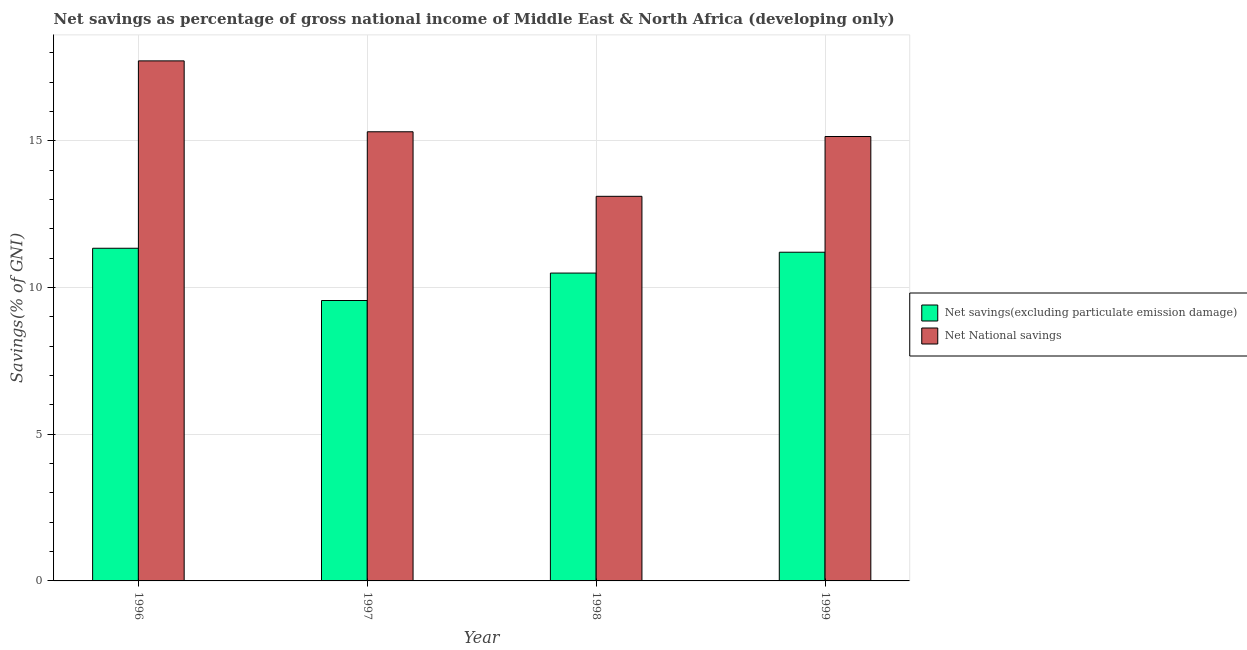How many groups of bars are there?
Offer a terse response. 4. How many bars are there on the 1st tick from the right?
Make the answer very short. 2. What is the label of the 1st group of bars from the left?
Your answer should be very brief. 1996. In how many cases, is the number of bars for a given year not equal to the number of legend labels?
Make the answer very short. 0. What is the net savings(excluding particulate emission damage) in 1996?
Your response must be concise. 11.34. Across all years, what is the maximum net national savings?
Your response must be concise. 17.72. Across all years, what is the minimum net savings(excluding particulate emission damage)?
Make the answer very short. 9.56. What is the total net national savings in the graph?
Your answer should be very brief. 61.28. What is the difference between the net savings(excluding particulate emission damage) in 1996 and that in 1998?
Your answer should be compact. 0.85. What is the difference between the net national savings in 1997 and the net savings(excluding particulate emission damage) in 1996?
Provide a short and direct response. -2.42. What is the average net national savings per year?
Offer a very short reply. 15.32. What is the ratio of the net savings(excluding particulate emission damage) in 1996 to that in 1997?
Make the answer very short. 1.19. Is the net savings(excluding particulate emission damage) in 1997 less than that in 1999?
Provide a short and direct response. Yes. What is the difference between the highest and the second highest net national savings?
Provide a succinct answer. 2.42. What is the difference between the highest and the lowest net national savings?
Your answer should be very brief. 4.62. In how many years, is the net national savings greater than the average net national savings taken over all years?
Ensure brevity in your answer.  1. What does the 1st bar from the left in 1999 represents?
Your response must be concise. Net savings(excluding particulate emission damage). What does the 1st bar from the right in 1996 represents?
Offer a terse response. Net National savings. How many bars are there?
Provide a short and direct response. 8. How many years are there in the graph?
Your response must be concise. 4. Does the graph contain any zero values?
Your response must be concise. No. Does the graph contain grids?
Make the answer very short. Yes. How are the legend labels stacked?
Offer a very short reply. Vertical. What is the title of the graph?
Offer a terse response. Net savings as percentage of gross national income of Middle East & North Africa (developing only). Does "Female labor force" appear as one of the legend labels in the graph?
Keep it short and to the point. No. What is the label or title of the X-axis?
Offer a very short reply. Year. What is the label or title of the Y-axis?
Offer a terse response. Savings(% of GNI). What is the Savings(% of GNI) of Net savings(excluding particulate emission damage) in 1996?
Make the answer very short. 11.34. What is the Savings(% of GNI) in Net National savings in 1996?
Give a very brief answer. 17.72. What is the Savings(% of GNI) of Net savings(excluding particulate emission damage) in 1997?
Provide a short and direct response. 9.56. What is the Savings(% of GNI) of Net National savings in 1997?
Your answer should be compact. 15.31. What is the Savings(% of GNI) of Net savings(excluding particulate emission damage) in 1998?
Ensure brevity in your answer.  10.49. What is the Savings(% of GNI) in Net National savings in 1998?
Your answer should be very brief. 13.11. What is the Savings(% of GNI) in Net savings(excluding particulate emission damage) in 1999?
Provide a short and direct response. 11.2. What is the Savings(% of GNI) of Net National savings in 1999?
Your response must be concise. 15.15. Across all years, what is the maximum Savings(% of GNI) in Net savings(excluding particulate emission damage)?
Provide a succinct answer. 11.34. Across all years, what is the maximum Savings(% of GNI) in Net National savings?
Make the answer very short. 17.72. Across all years, what is the minimum Savings(% of GNI) of Net savings(excluding particulate emission damage)?
Make the answer very short. 9.56. Across all years, what is the minimum Savings(% of GNI) in Net National savings?
Ensure brevity in your answer.  13.11. What is the total Savings(% of GNI) of Net savings(excluding particulate emission damage) in the graph?
Provide a short and direct response. 42.59. What is the total Savings(% of GNI) of Net National savings in the graph?
Your answer should be compact. 61.28. What is the difference between the Savings(% of GNI) of Net savings(excluding particulate emission damage) in 1996 and that in 1997?
Provide a short and direct response. 1.78. What is the difference between the Savings(% of GNI) of Net National savings in 1996 and that in 1997?
Provide a short and direct response. 2.42. What is the difference between the Savings(% of GNI) in Net savings(excluding particulate emission damage) in 1996 and that in 1998?
Ensure brevity in your answer.  0.85. What is the difference between the Savings(% of GNI) in Net National savings in 1996 and that in 1998?
Your answer should be very brief. 4.62. What is the difference between the Savings(% of GNI) of Net savings(excluding particulate emission damage) in 1996 and that in 1999?
Provide a succinct answer. 0.14. What is the difference between the Savings(% of GNI) in Net National savings in 1996 and that in 1999?
Make the answer very short. 2.58. What is the difference between the Savings(% of GNI) of Net savings(excluding particulate emission damage) in 1997 and that in 1998?
Offer a terse response. -0.93. What is the difference between the Savings(% of GNI) in Net National savings in 1997 and that in 1998?
Your answer should be compact. 2.2. What is the difference between the Savings(% of GNI) in Net savings(excluding particulate emission damage) in 1997 and that in 1999?
Provide a short and direct response. -1.65. What is the difference between the Savings(% of GNI) in Net National savings in 1997 and that in 1999?
Make the answer very short. 0.16. What is the difference between the Savings(% of GNI) in Net savings(excluding particulate emission damage) in 1998 and that in 1999?
Keep it short and to the point. -0.71. What is the difference between the Savings(% of GNI) of Net National savings in 1998 and that in 1999?
Offer a very short reply. -2.04. What is the difference between the Savings(% of GNI) in Net savings(excluding particulate emission damage) in 1996 and the Savings(% of GNI) in Net National savings in 1997?
Your answer should be compact. -3.97. What is the difference between the Savings(% of GNI) in Net savings(excluding particulate emission damage) in 1996 and the Savings(% of GNI) in Net National savings in 1998?
Ensure brevity in your answer.  -1.77. What is the difference between the Savings(% of GNI) in Net savings(excluding particulate emission damage) in 1996 and the Savings(% of GNI) in Net National savings in 1999?
Your response must be concise. -3.81. What is the difference between the Savings(% of GNI) of Net savings(excluding particulate emission damage) in 1997 and the Savings(% of GNI) of Net National savings in 1998?
Your response must be concise. -3.55. What is the difference between the Savings(% of GNI) in Net savings(excluding particulate emission damage) in 1997 and the Savings(% of GNI) in Net National savings in 1999?
Your answer should be compact. -5.59. What is the difference between the Savings(% of GNI) of Net savings(excluding particulate emission damage) in 1998 and the Savings(% of GNI) of Net National savings in 1999?
Keep it short and to the point. -4.65. What is the average Savings(% of GNI) in Net savings(excluding particulate emission damage) per year?
Keep it short and to the point. 10.65. What is the average Savings(% of GNI) of Net National savings per year?
Provide a short and direct response. 15.32. In the year 1996, what is the difference between the Savings(% of GNI) of Net savings(excluding particulate emission damage) and Savings(% of GNI) of Net National savings?
Offer a very short reply. -6.39. In the year 1997, what is the difference between the Savings(% of GNI) of Net savings(excluding particulate emission damage) and Savings(% of GNI) of Net National savings?
Provide a short and direct response. -5.75. In the year 1998, what is the difference between the Savings(% of GNI) of Net savings(excluding particulate emission damage) and Savings(% of GNI) of Net National savings?
Your answer should be compact. -2.62. In the year 1999, what is the difference between the Savings(% of GNI) of Net savings(excluding particulate emission damage) and Savings(% of GNI) of Net National savings?
Your response must be concise. -3.94. What is the ratio of the Savings(% of GNI) of Net savings(excluding particulate emission damage) in 1996 to that in 1997?
Your response must be concise. 1.19. What is the ratio of the Savings(% of GNI) of Net National savings in 1996 to that in 1997?
Your response must be concise. 1.16. What is the ratio of the Savings(% of GNI) of Net savings(excluding particulate emission damage) in 1996 to that in 1998?
Ensure brevity in your answer.  1.08. What is the ratio of the Savings(% of GNI) in Net National savings in 1996 to that in 1998?
Keep it short and to the point. 1.35. What is the ratio of the Savings(% of GNI) of Net savings(excluding particulate emission damage) in 1996 to that in 1999?
Ensure brevity in your answer.  1.01. What is the ratio of the Savings(% of GNI) of Net National savings in 1996 to that in 1999?
Your answer should be very brief. 1.17. What is the ratio of the Savings(% of GNI) of Net savings(excluding particulate emission damage) in 1997 to that in 1998?
Ensure brevity in your answer.  0.91. What is the ratio of the Savings(% of GNI) in Net National savings in 1997 to that in 1998?
Offer a very short reply. 1.17. What is the ratio of the Savings(% of GNI) in Net savings(excluding particulate emission damage) in 1997 to that in 1999?
Offer a terse response. 0.85. What is the ratio of the Savings(% of GNI) in Net National savings in 1997 to that in 1999?
Provide a short and direct response. 1.01. What is the ratio of the Savings(% of GNI) in Net savings(excluding particulate emission damage) in 1998 to that in 1999?
Offer a terse response. 0.94. What is the ratio of the Savings(% of GNI) in Net National savings in 1998 to that in 1999?
Offer a very short reply. 0.87. What is the difference between the highest and the second highest Savings(% of GNI) of Net savings(excluding particulate emission damage)?
Give a very brief answer. 0.14. What is the difference between the highest and the second highest Savings(% of GNI) in Net National savings?
Ensure brevity in your answer.  2.42. What is the difference between the highest and the lowest Savings(% of GNI) in Net savings(excluding particulate emission damage)?
Make the answer very short. 1.78. What is the difference between the highest and the lowest Savings(% of GNI) of Net National savings?
Make the answer very short. 4.62. 